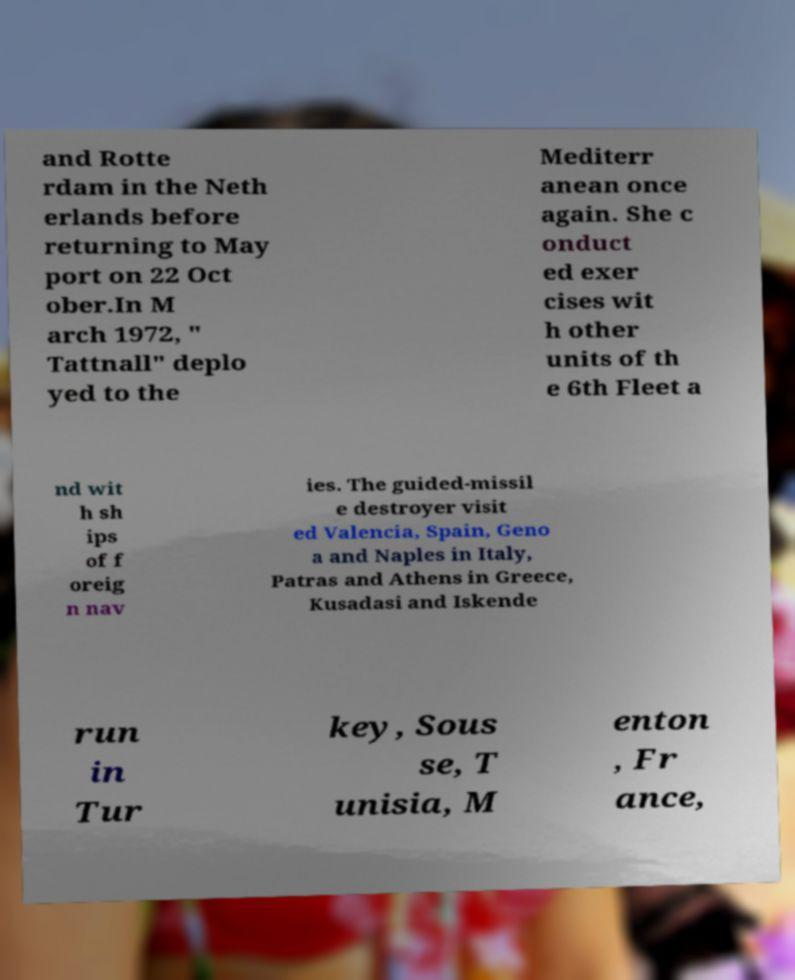Could you assist in decoding the text presented in this image and type it out clearly? and Rotte rdam in the Neth erlands before returning to May port on 22 Oct ober.In M arch 1972, " Tattnall" deplo yed to the Mediterr anean once again. She c onduct ed exer cises wit h other units of th e 6th Fleet a nd wit h sh ips of f oreig n nav ies. The guided-missil e destroyer visit ed Valencia, Spain, Geno a and Naples in Italy, Patras and Athens in Greece, Kusadasi and Iskende run in Tur key, Sous se, T unisia, M enton , Fr ance, 